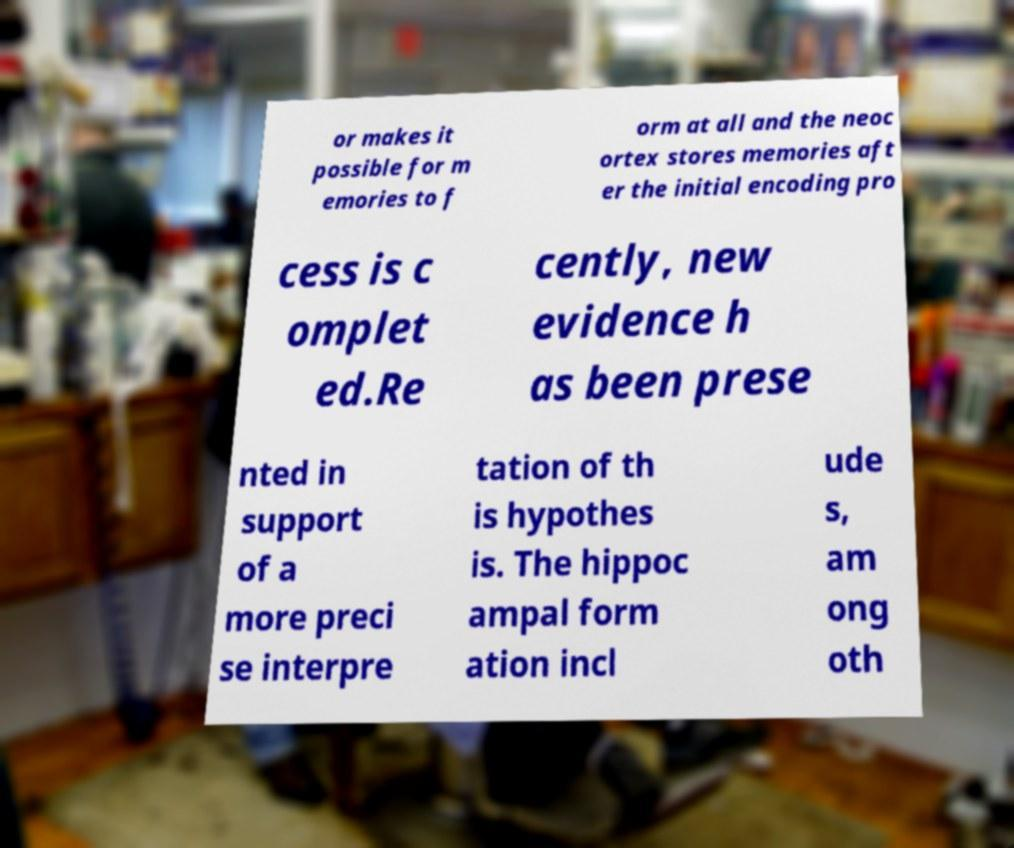Could you extract and type out the text from this image? or makes it possible for m emories to f orm at all and the neoc ortex stores memories aft er the initial encoding pro cess is c omplet ed.Re cently, new evidence h as been prese nted in support of a more preci se interpre tation of th is hypothes is. The hippoc ampal form ation incl ude s, am ong oth 